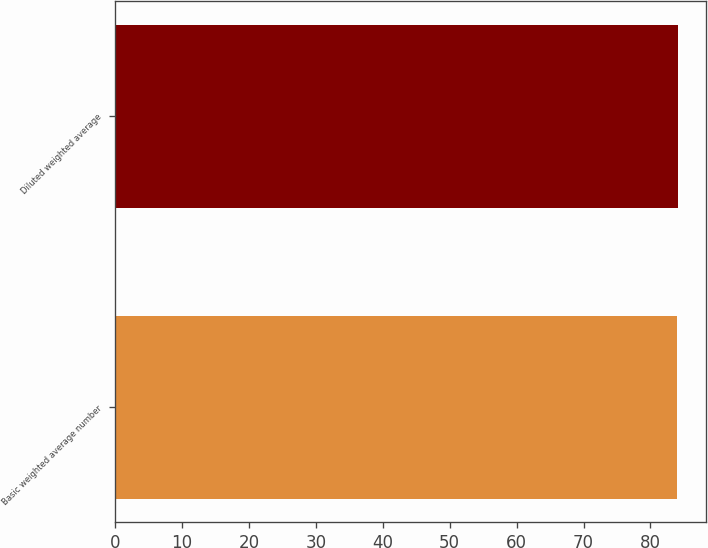<chart> <loc_0><loc_0><loc_500><loc_500><bar_chart><fcel>Basic weighted average number<fcel>Diluted weighted average<nl><fcel>84<fcel>84.1<nl></chart> 